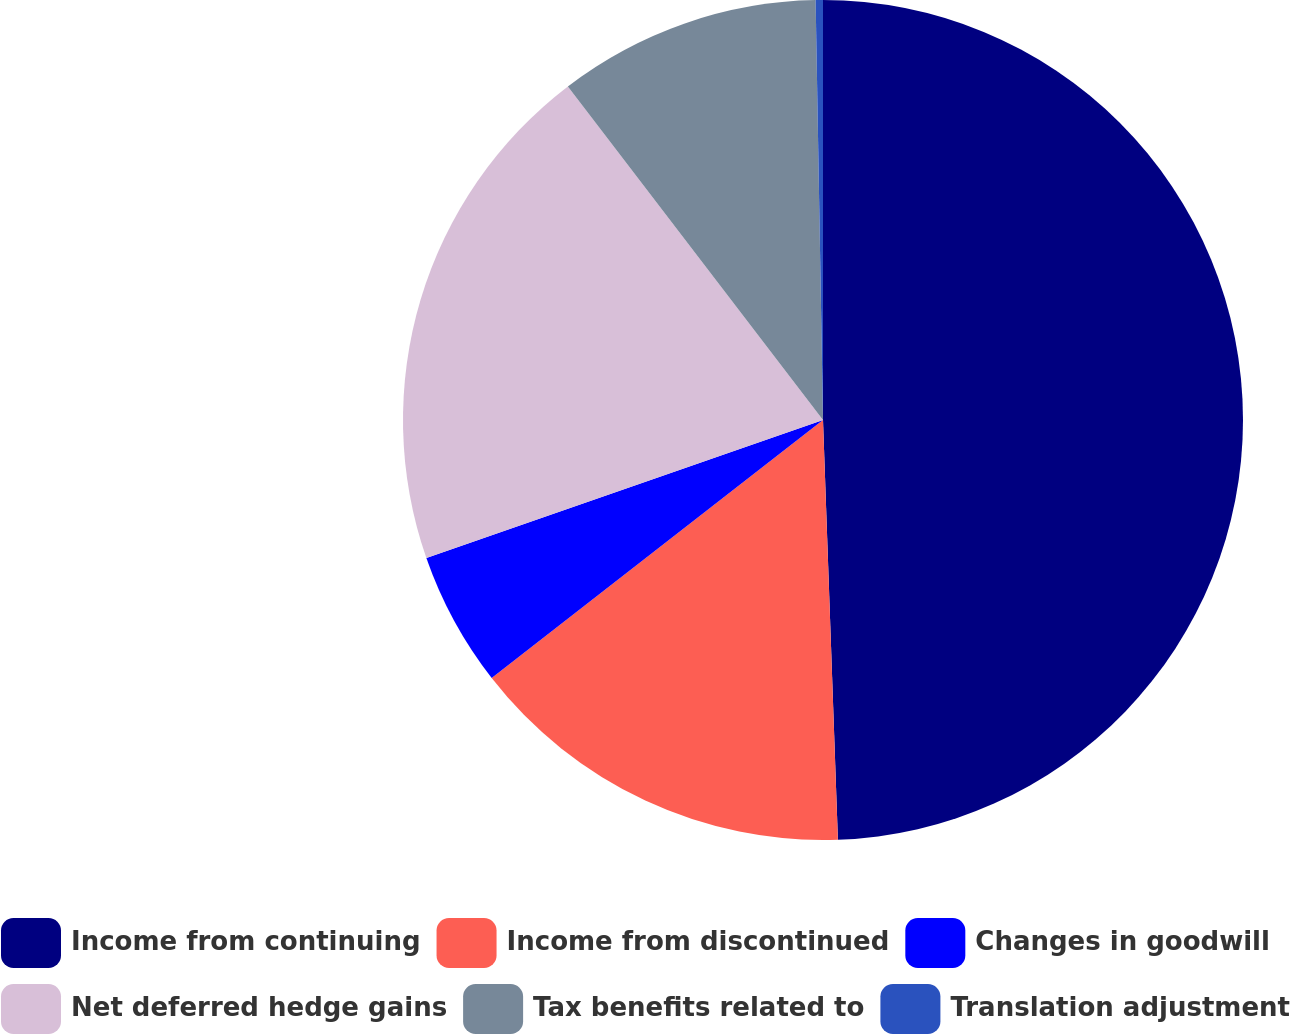Convert chart. <chart><loc_0><loc_0><loc_500><loc_500><pie_chart><fcel>Income from continuing<fcel>Income from discontinued<fcel>Changes in goodwill<fcel>Net deferred hedge gains<fcel>Tax benefits related to<fcel>Translation adjustment<nl><fcel>49.43%<fcel>15.03%<fcel>5.2%<fcel>19.94%<fcel>10.11%<fcel>0.28%<nl></chart> 